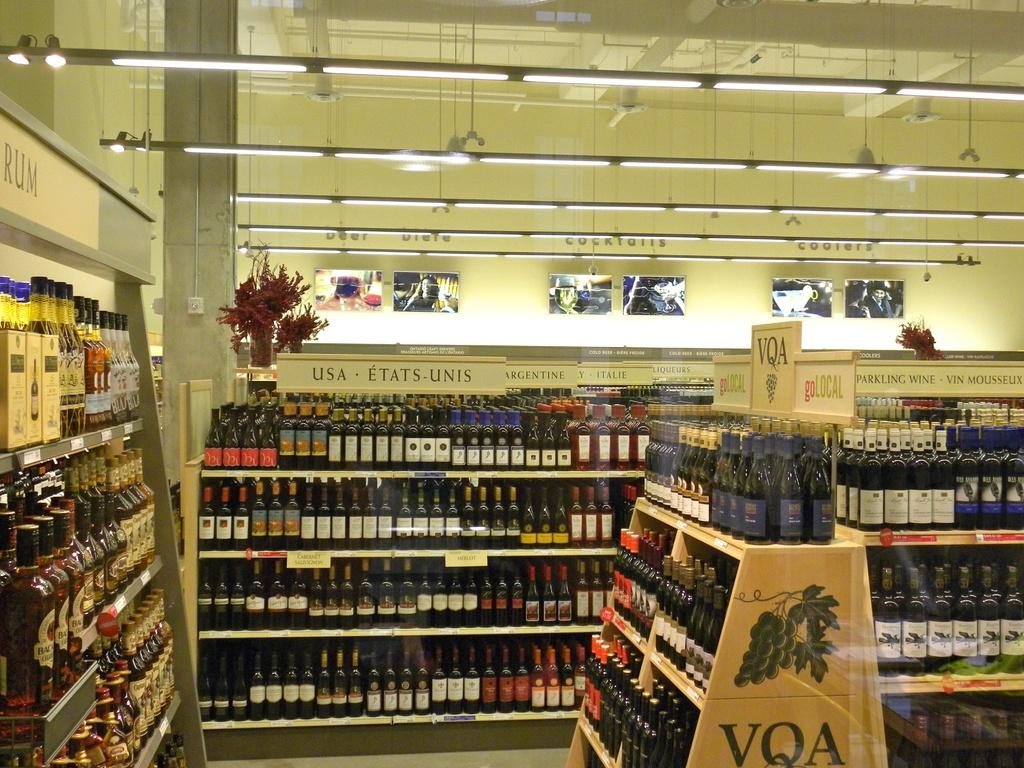Provide a one-sentence caption for the provided image. An aisle in a liquor store which has the bottles all on shelves under signs depicting the region that they came from. 